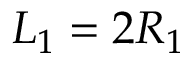<formula> <loc_0><loc_0><loc_500><loc_500>L _ { 1 } = 2 R _ { 1 }</formula> 